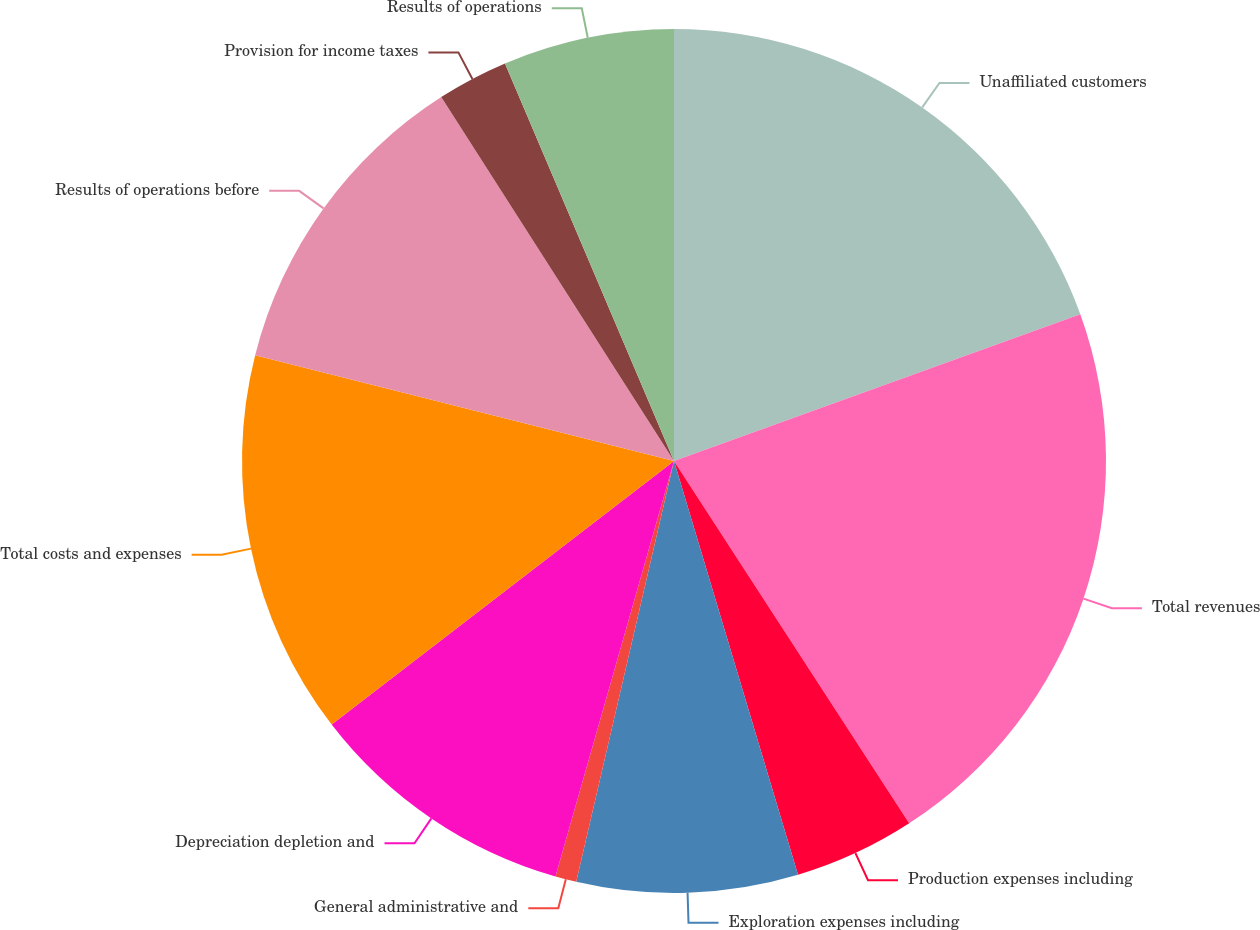<chart> <loc_0><loc_0><loc_500><loc_500><pie_chart><fcel>Unaffiliated customers<fcel>Total revenues<fcel>Production expenses including<fcel>Exploration expenses including<fcel>General administrative and<fcel>Depreciation depletion and<fcel>Total costs and expenses<fcel>Results of operations before<fcel>Provision for income taxes<fcel>Results of operations<nl><fcel>19.49%<fcel>21.36%<fcel>4.53%<fcel>8.27%<fcel>0.79%<fcel>10.14%<fcel>14.38%<fcel>12.01%<fcel>2.66%<fcel>6.4%<nl></chart> 